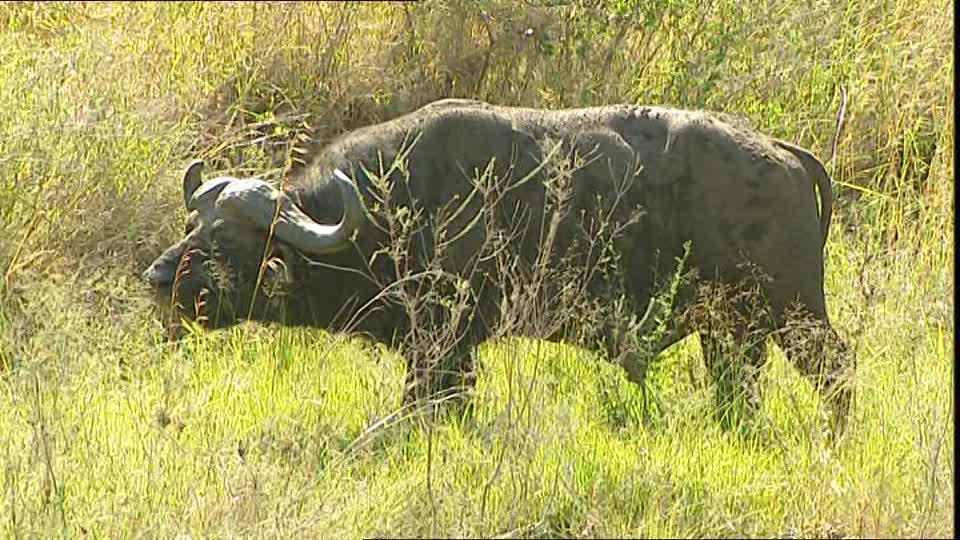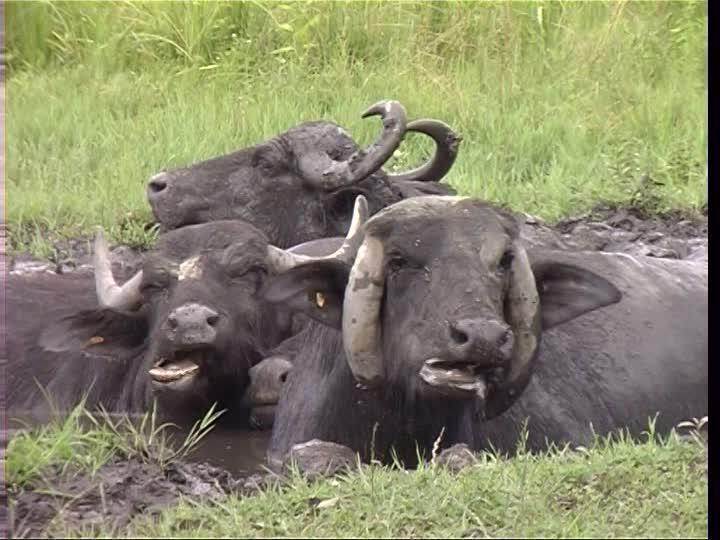The first image is the image on the left, the second image is the image on the right. Assess this claim about the two images: "The bull on the left image is facing left.". Correct or not? Answer yes or no. Yes. 